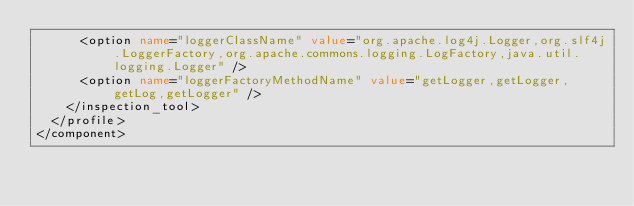<code> <loc_0><loc_0><loc_500><loc_500><_XML_>      <option name="loggerClassName" value="org.apache.log4j.Logger,org.slf4j.LoggerFactory,org.apache.commons.logging.LogFactory,java.util.logging.Logger" />
      <option name="loggerFactoryMethodName" value="getLogger,getLogger,getLog,getLogger" />
    </inspection_tool>
  </profile>
</component></code> 